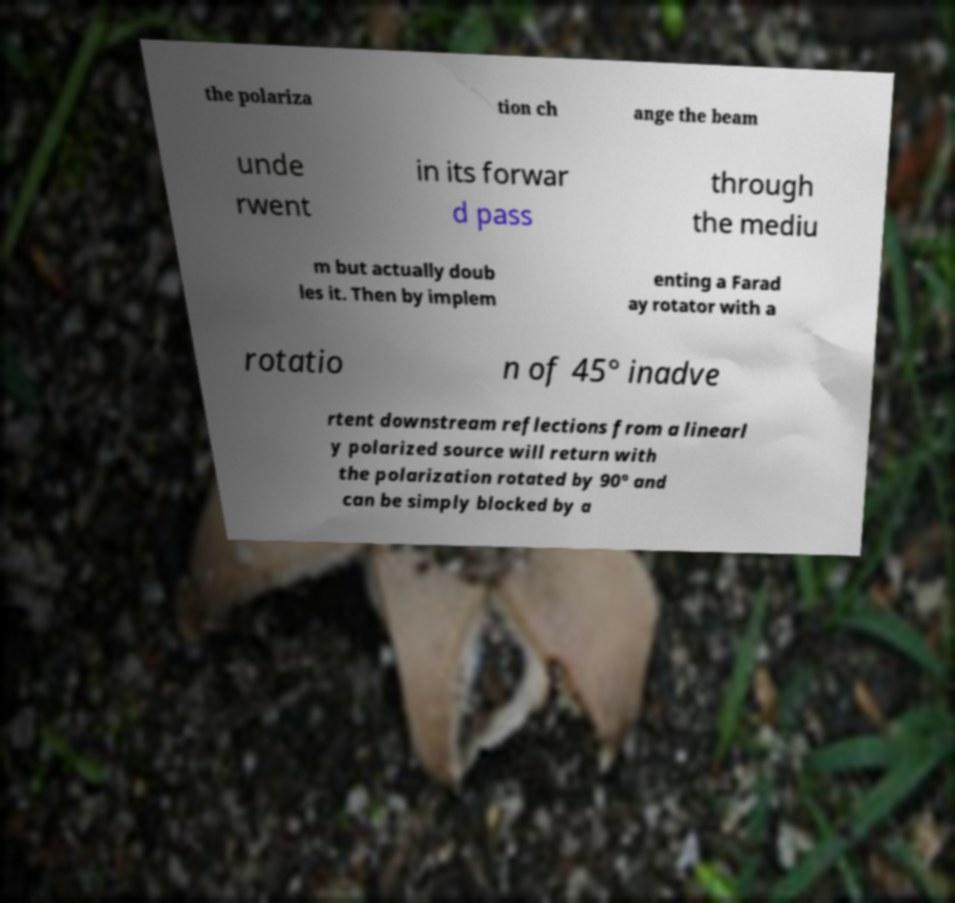Please identify and transcribe the text found in this image. the polariza tion ch ange the beam unde rwent in its forwar d pass through the mediu m but actually doub les it. Then by implem enting a Farad ay rotator with a rotatio n of 45° inadve rtent downstream reflections from a linearl y polarized source will return with the polarization rotated by 90° and can be simply blocked by a 